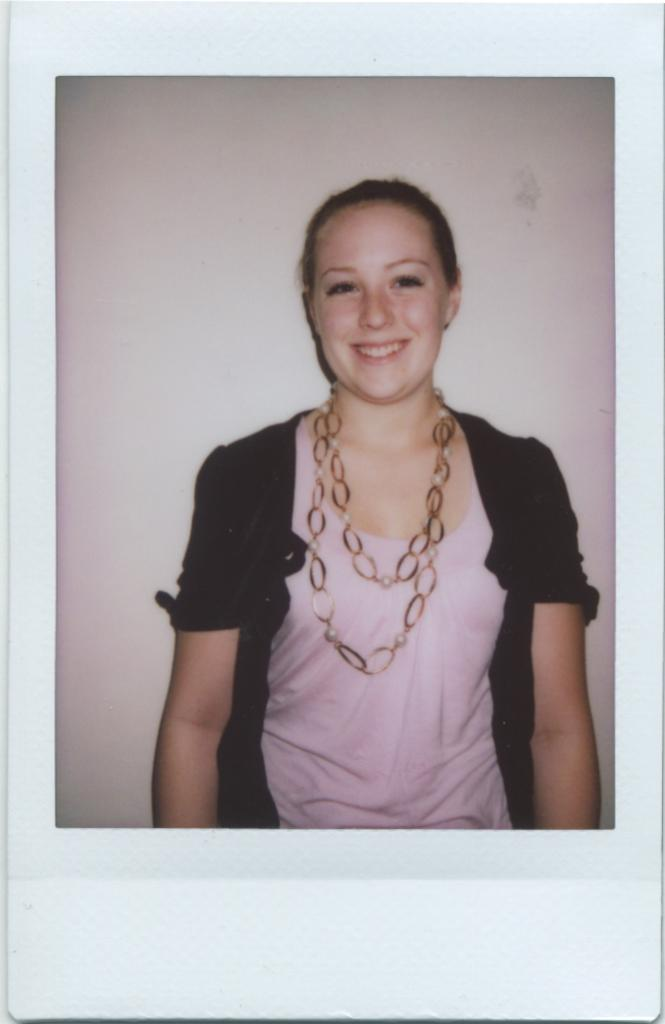Who is present in the image? There is a woman in the picture. What is the woman's facial expression? The woman is smiling. What accessory is the woman wearing? The woman is wearing a necklace. What is the woman wearing that covers her body? The woman is wearing clothes. What type of bomb is the woman holding in the image? There is no bomb present in the image; the woman is not holding anything. 